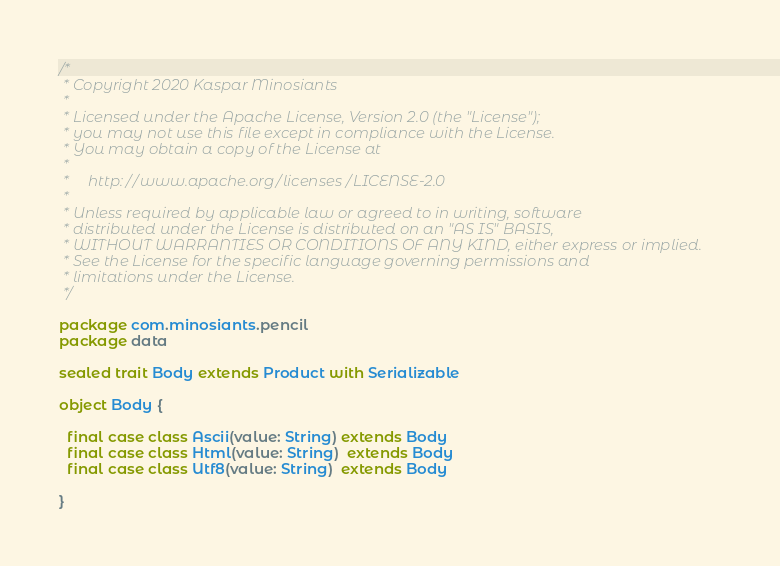<code> <loc_0><loc_0><loc_500><loc_500><_Scala_>/*
 * Copyright 2020 Kaspar Minosiants
 *
 * Licensed under the Apache License, Version 2.0 (the "License");
 * you may not use this file except in compliance with the License.
 * You may obtain a copy of the License at
 *
 *     http://www.apache.org/licenses/LICENSE-2.0
 *
 * Unless required by applicable law or agreed to in writing, software
 * distributed under the License is distributed on an "AS IS" BASIS,
 * WITHOUT WARRANTIES OR CONDITIONS OF ANY KIND, either express or implied.
 * See the License for the specific language governing permissions and
 * limitations under the License.
 */

package com.minosiants.pencil
package data

sealed trait Body extends Product with Serializable

object Body {

  final case class Ascii(value: String) extends Body
  final case class Html(value: String)  extends Body
  final case class Utf8(value: String)  extends Body

}
</code> 